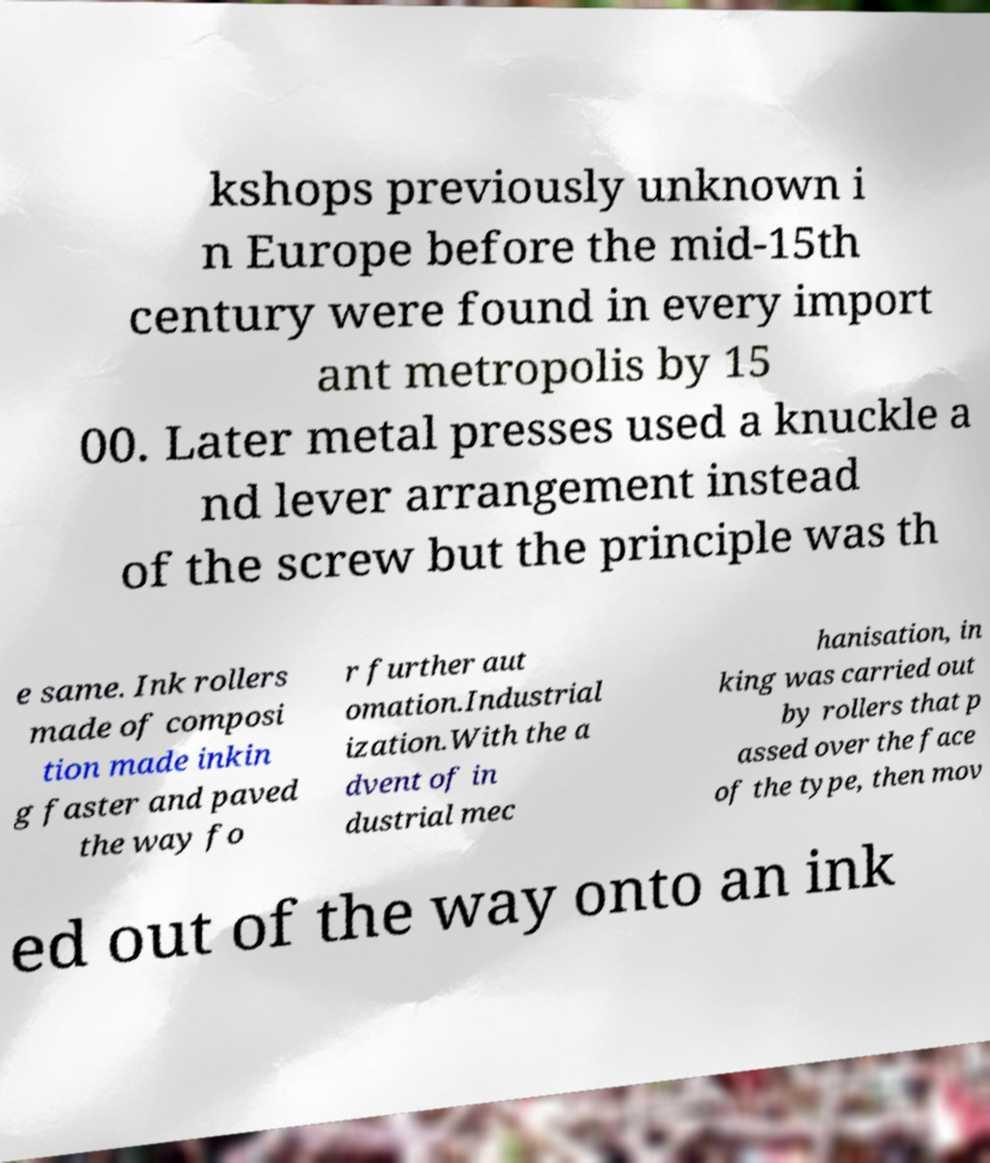Please read and relay the text visible in this image. What does it say? kshops previously unknown i n Europe before the mid-15th century were found in every import ant metropolis by 15 00. Later metal presses used a knuckle a nd lever arrangement instead of the screw but the principle was th e same. Ink rollers made of composi tion made inkin g faster and paved the way fo r further aut omation.Industrial ization.With the a dvent of in dustrial mec hanisation, in king was carried out by rollers that p assed over the face of the type, then mov ed out of the way onto an ink 